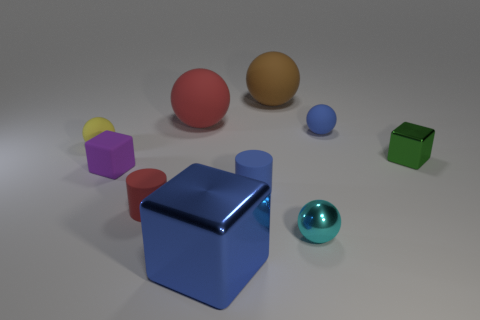What could be the use of these objects in a real-world setting? These objects could serve various purposes. The cubes might be toy blocks for children, aiding in cognitive development and motor skills. The spheres might be decorative elements or part of a desktop game, and the cylinders could be used for stacking or rolling games, also potentially in educational settings. 